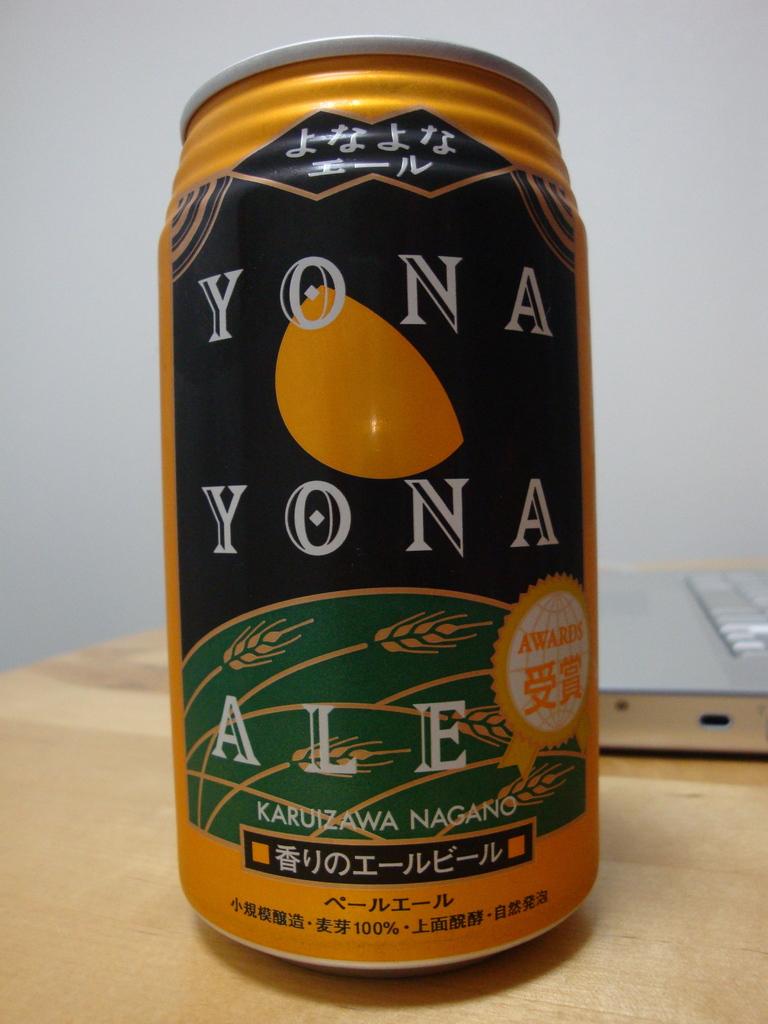What brand of beer is this?
Make the answer very short. Yona yona. 